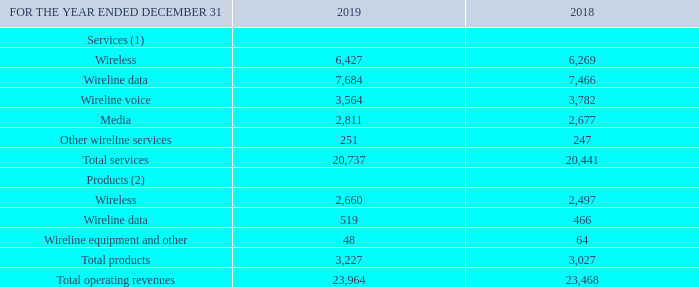REVENUES BY SERVICES AND PRODUCTS
The following table presents our revenues disaggregated by type of services and products.
(1) Our service revenues are generally recognized over time.
(2) Our product revenues are generally recognized at a point in time.
How are the service revenues generally recognized? Over time. How are the product revenues generally recognized? At a point in time. What are the total operating revenues for 2019? 23,964. How many categories are there under services? Wireless##Wireline data##Wireline voice##Media##Other wireline services
Answer: 5. What is the average annual Total services? (20,737+20,441)/2
Answer: 20589. Which segment when disaggregated has more types? 5>3
Answer: services. 